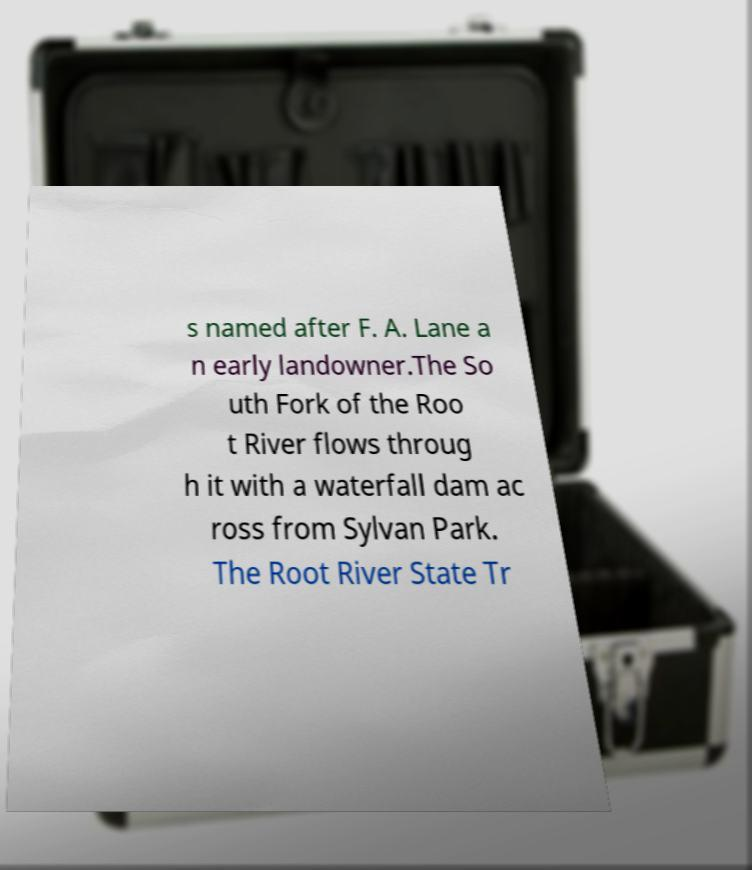Please read and relay the text visible in this image. What does it say? s named after F. A. Lane a n early landowner.The So uth Fork of the Roo t River flows throug h it with a waterfall dam ac ross from Sylvan Park. The Root River State Tr 